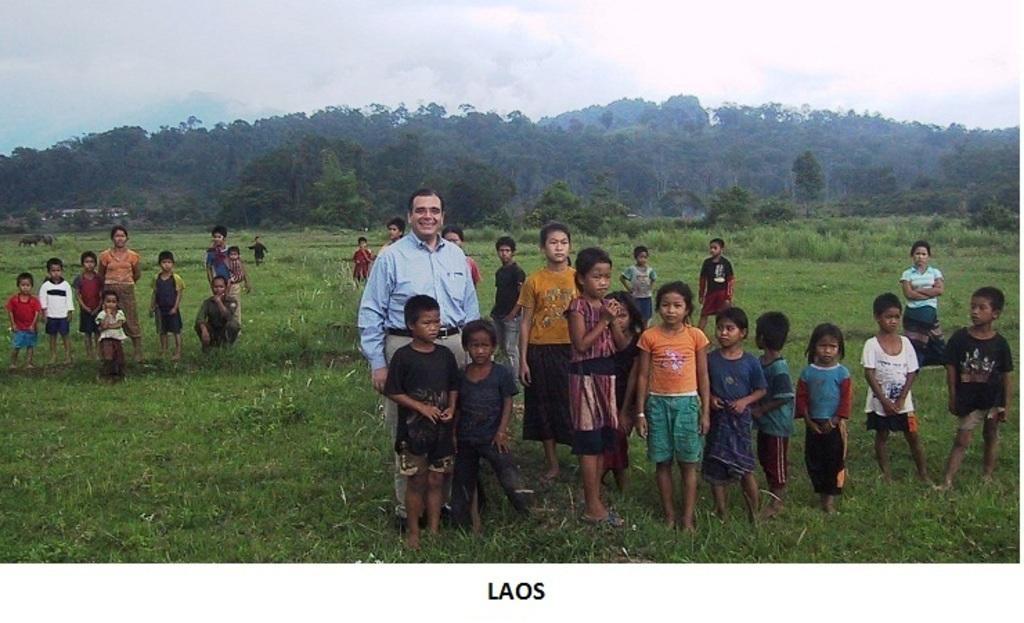Describe this image in one or two sentences. At the top of the image we can see sky with clouds, trees, buildings and animals. At the bottom of the image we can see people standing on the grass. 